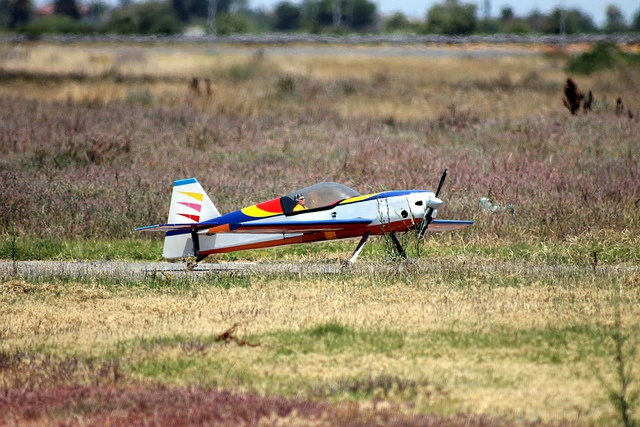Describe the objects in this image and their specific colors. I can see airplane in darkblue, lightgray, darkgray, black, and maroon tones and people in darkblue, gold, black, brown, and gray tones in this image. 